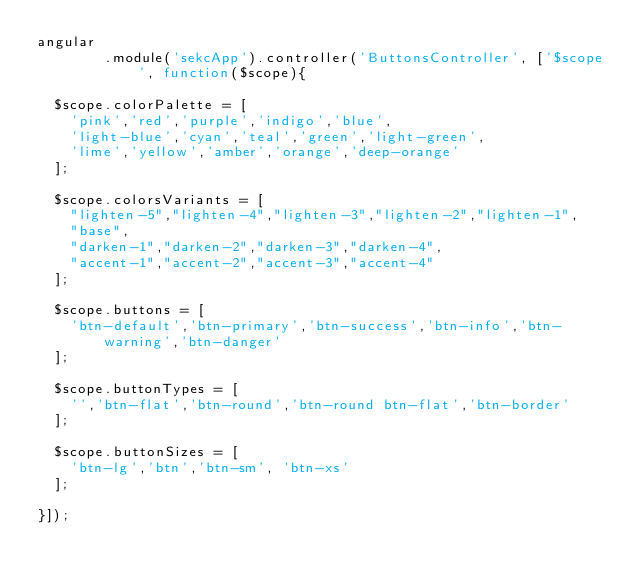Convert code to text. <code><loc_0><loc_0><loc_500><loc_500><_JavaScript_>angular
        .module('sekcApp').controller('ButtonsController', ['$scope', function($scope){

  $scope.colorPalette = [
    'pink','red','purple','indigo','blue',
    'light-blue','cyan','teal','green','light-green',
    'lime','yellow','amber','orange','deep-orange'
  ];

  $scope.colorsVariants = [
    "lighten-5","lighten-4","lighten-3","lighten-2","lighten-1",
    "base",
    "darken-1","darken-2","darken-3","darken-4",
    "accent-1","accent-2","accent-3","accent-4"
  ];

  $scope.buttons = [
    'btn-default','btn-primary','btn-success','btn-info','btn-warning','btn-danger'
  ];

  $scope.buttonTypes = [
    '','btn-flat','btn-round','btn-round btn-flat','btn-border'
  ];

  $scope.buttonSizes = [
    'btn-lg','btn','btn-sm', 'btn-xs'
  ];

}]);

</code> 